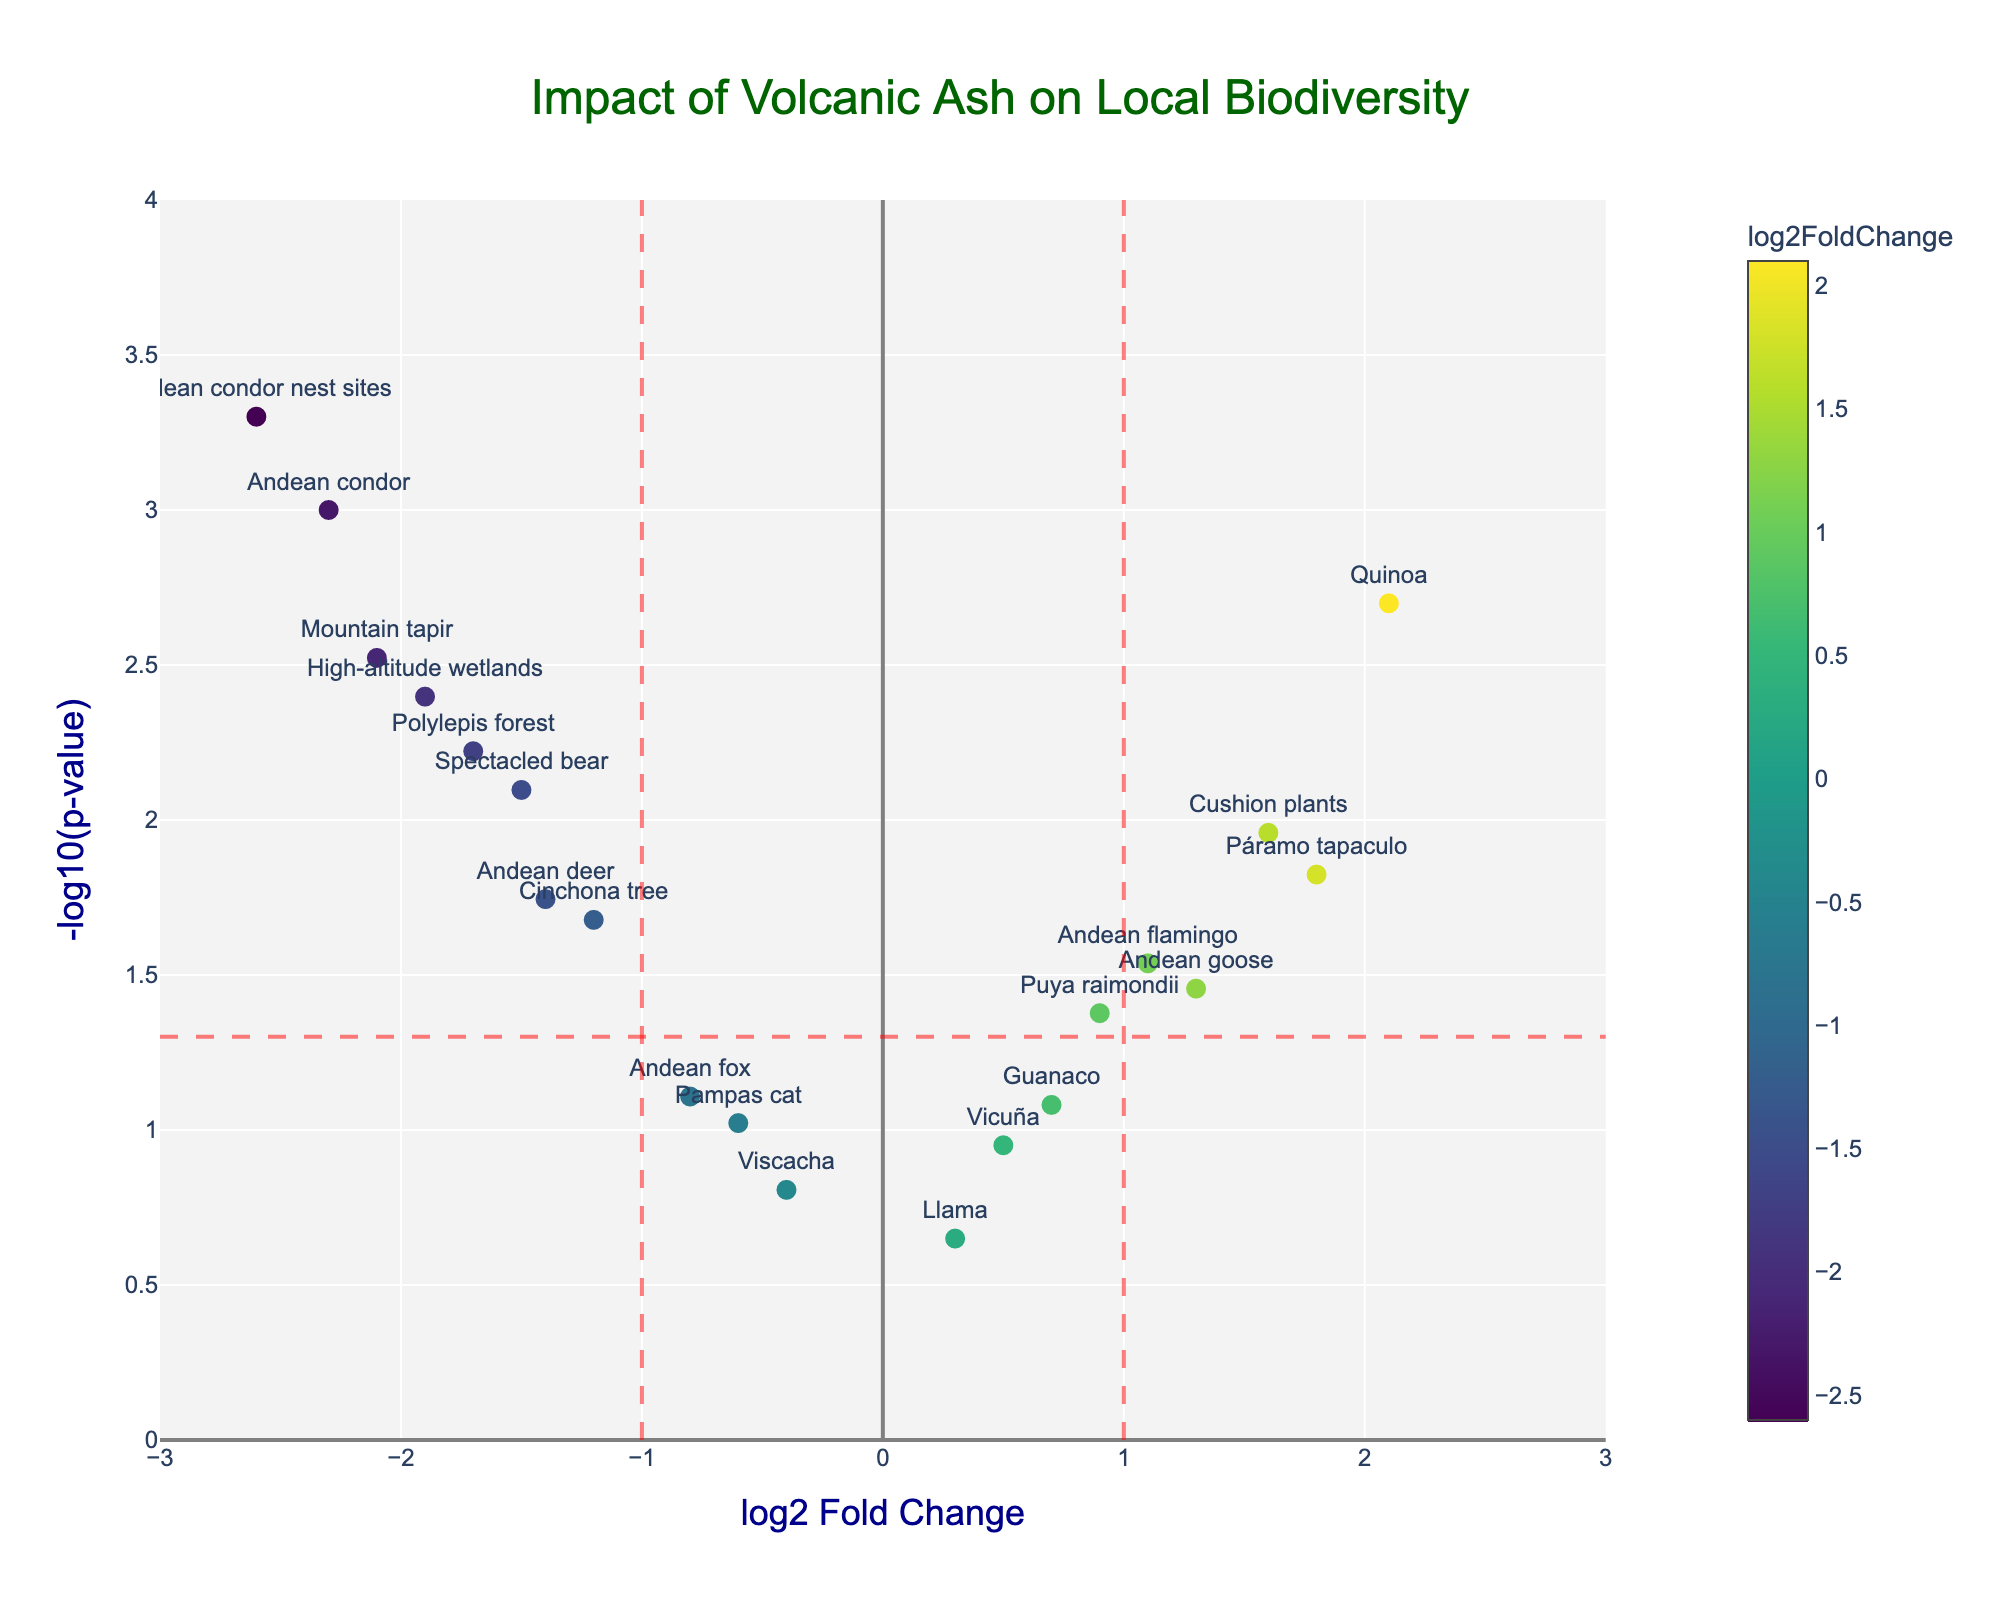What's the title of the figure? The title is prominently displayed at the top of the figure.
Answer: Impact of Volcanic Ash on Local Biodiversity What is the range of the x-axis? The x-axis represents the log2 Fold Change, and from the figure, the axis ranges from -3 to 3.
Answer: -3 to 3 Which species is most negatively impacted according to log2 Fold Change? By looking for the point farthest on the left on the x-axis, which has the most negative log2 Fold Change, it is clear that it is the "Andean condor nest sites" with a value of -2.6.
Answer: Andean condor nest sites How many species show a statistically significant impact (p-value < 0.05)? Points above the horizontal dashed line represent species with significant p-values (p-value < 0.05). If we count these points, we see a total of 15.
Answer: 15 Which species has the highest log2 Fold Change? By finding the point farthest on the right on the x-axis, we see that "Quinoa" has the highest log2 Fold Change at 2.1.
Answer: Quinoa Which species has the highest p-value among those significantly impacted? Among the points above the horizontal dashed line (significant p-value), we check their y-axis values to find the one with the lowest height, which is "Puya raimondii" with a p-value of 0.042.
Answer: Puya raimondii How does "Cushion plants" compare to "Páramo tapaculo" in terms of log2 Fold Change and p-value? "Cushion plants" have a log2 Fold Change of 1.6 and a p-value of 0.011, while "Páramo tapaculo" has a log2 Fold Change of 1.8 and a p-value of 0.015. Although "Páramo tapaculo" has a slightly higher log2 Fold Change, it also has a slightly higher (less significant) p-value compared to "Cushion plants."
Answer: Páramo tapaculo has a higher log2 Fold Change but a less significant p-value Which species have a log2 Fold Change > 1 and are statistically significant? We filter the points by looking to the right of the vertical dashed line at x = 1 and above the horizontal dashed line (significant p-value). The species satisfying these conditions are "Quinoa," "Páramo tapaculo," and "Cushion plants."
Answer: Quinoa, Páramo tapaculo, Cushion plants Is any species both positively impacted (log2 Fold Change > 0) and not statistically significant (p-value ≥ 0.05)? Points to the right of the y-axis (positive log2 Fold Change) and below the horizontal dashed line (p-value ≥ 0.05) indicate such species. These species are "Vicuña," "Llama," and "Guanaco."
Answer: Vicuña, Llama, Guanaco 